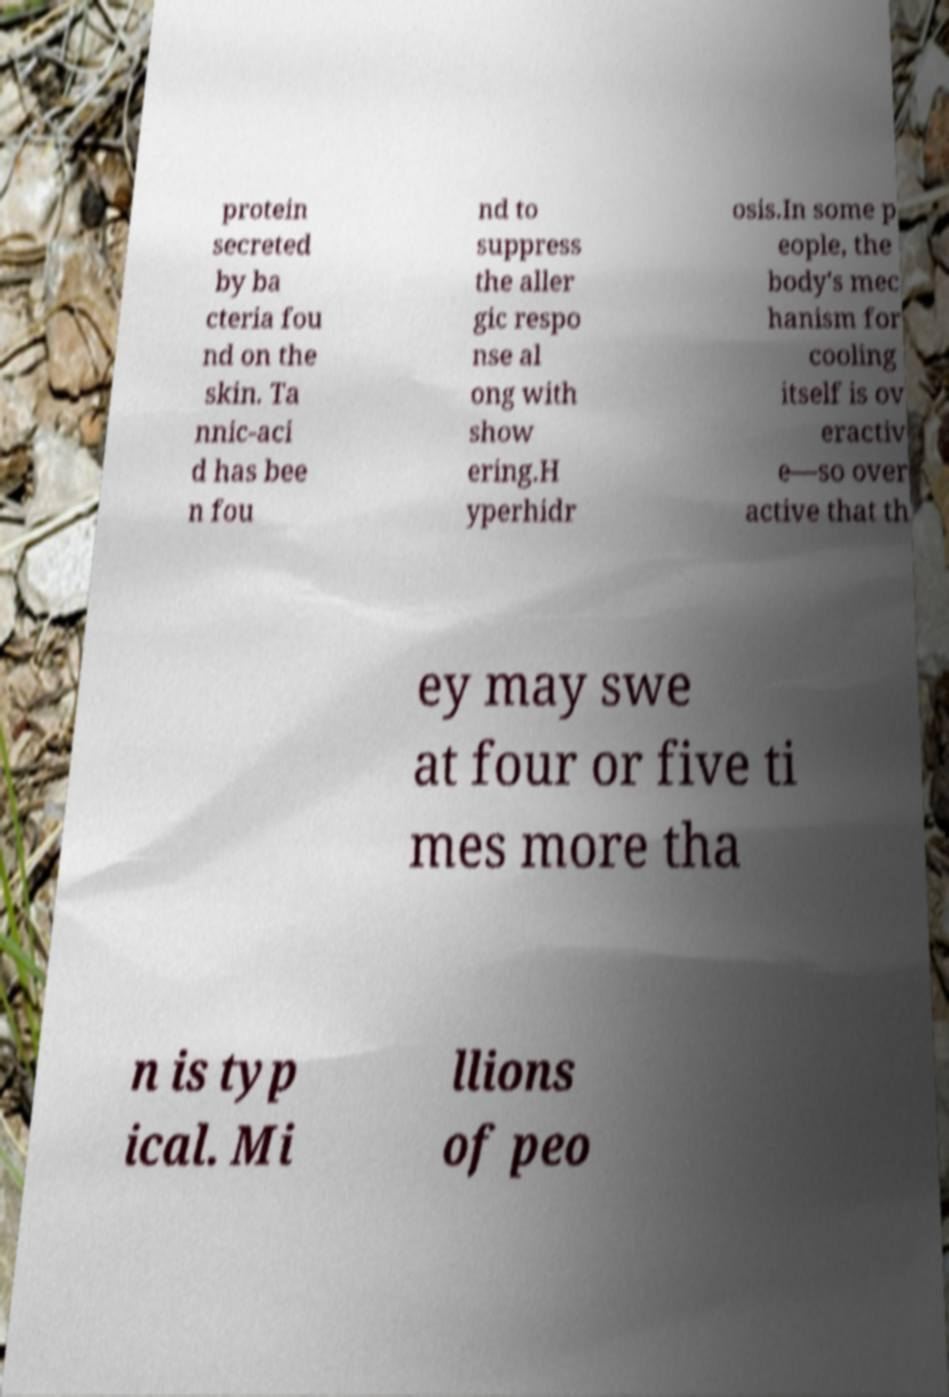There's text embedded in this image that I need extracted. Can you transcribe it verbatim? protein secreted by ba cteria fou nd on the skin. Ta nnic-aci d has bee n fou nd to suppress the aller gic respo nse al ong with show ering.H yperhidr osis.In some p eople, the body's mec hanism for cooling itself is ov eractiv e—so over active that th ey may swe at four or five ti mes more tha n is typ ical. Mi llions of peo 